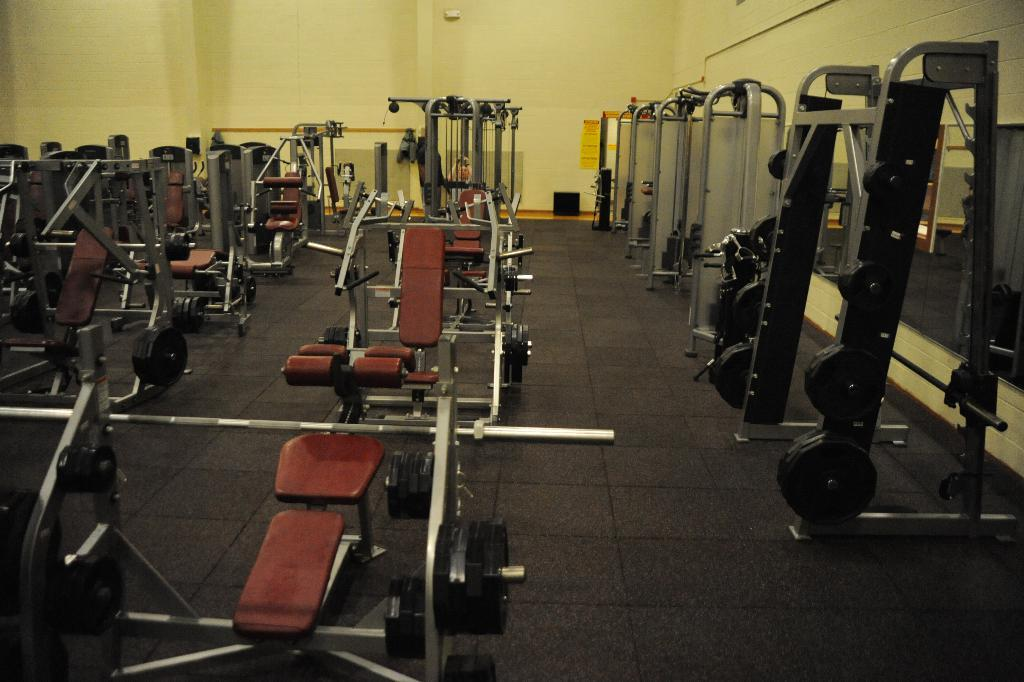What type of equipment can be seen in the foreground of the image? There is gym equipment in the foreground of the image. What is visible in the background of the image? There is a wall in the background of the image. How many houses can be seen in the image? There are no houses visible in the image. What type of pet is present in the image? There is no pet present in the image. 